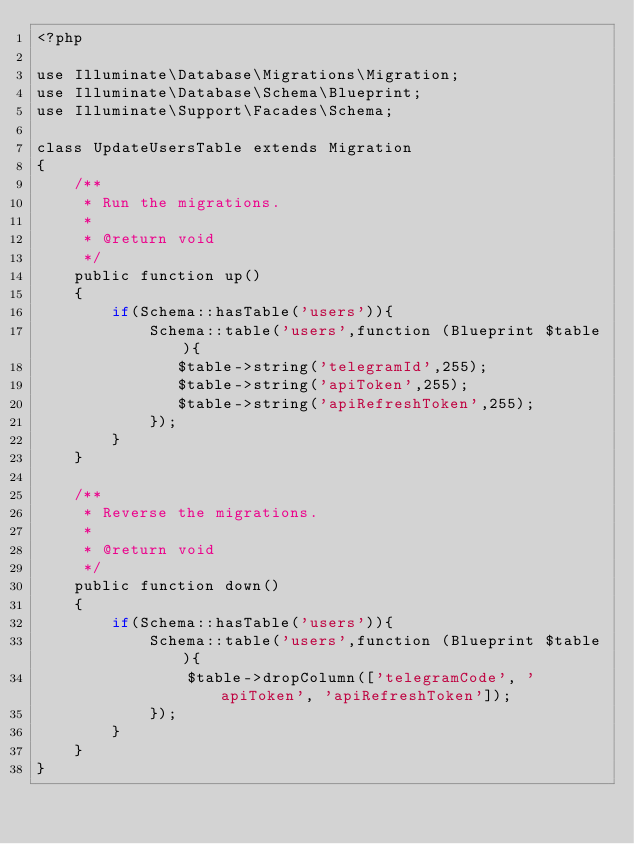<code> <loc_0><loc_0><loc_500><loc_500><_PHP_><?php

use Illuminate\Database\Migrations\Migration;
use Illuminate\Database\Schema\Blueprint;
use Illuminate\Support\Facades\Schema;

class UpdateUsersTable extends Migration
{
    /**
     * Run the migrations.
     *
     * @return void
     */
    public function up()
    {
        if(Schema::hasTable('users')){
            Schema::table('users',function (Blueprint $table){
               $table->string('telegramId',255);
               $table->string('apiToken',255);
               $table->string('apiRefreshToken',255);
            });
        }
    }

    /**
     * Reverse the migrations.
     *
     * @return void
     */
    public function down()
    {
        if(Schema::hasTable('users')){
            Schema::table('users',function (Blueprint $table){
                $table->dropColumn(['telegramCode', 'apiToken', 'apiRefreshToken']);
            });
        }
    }
}
</code> 